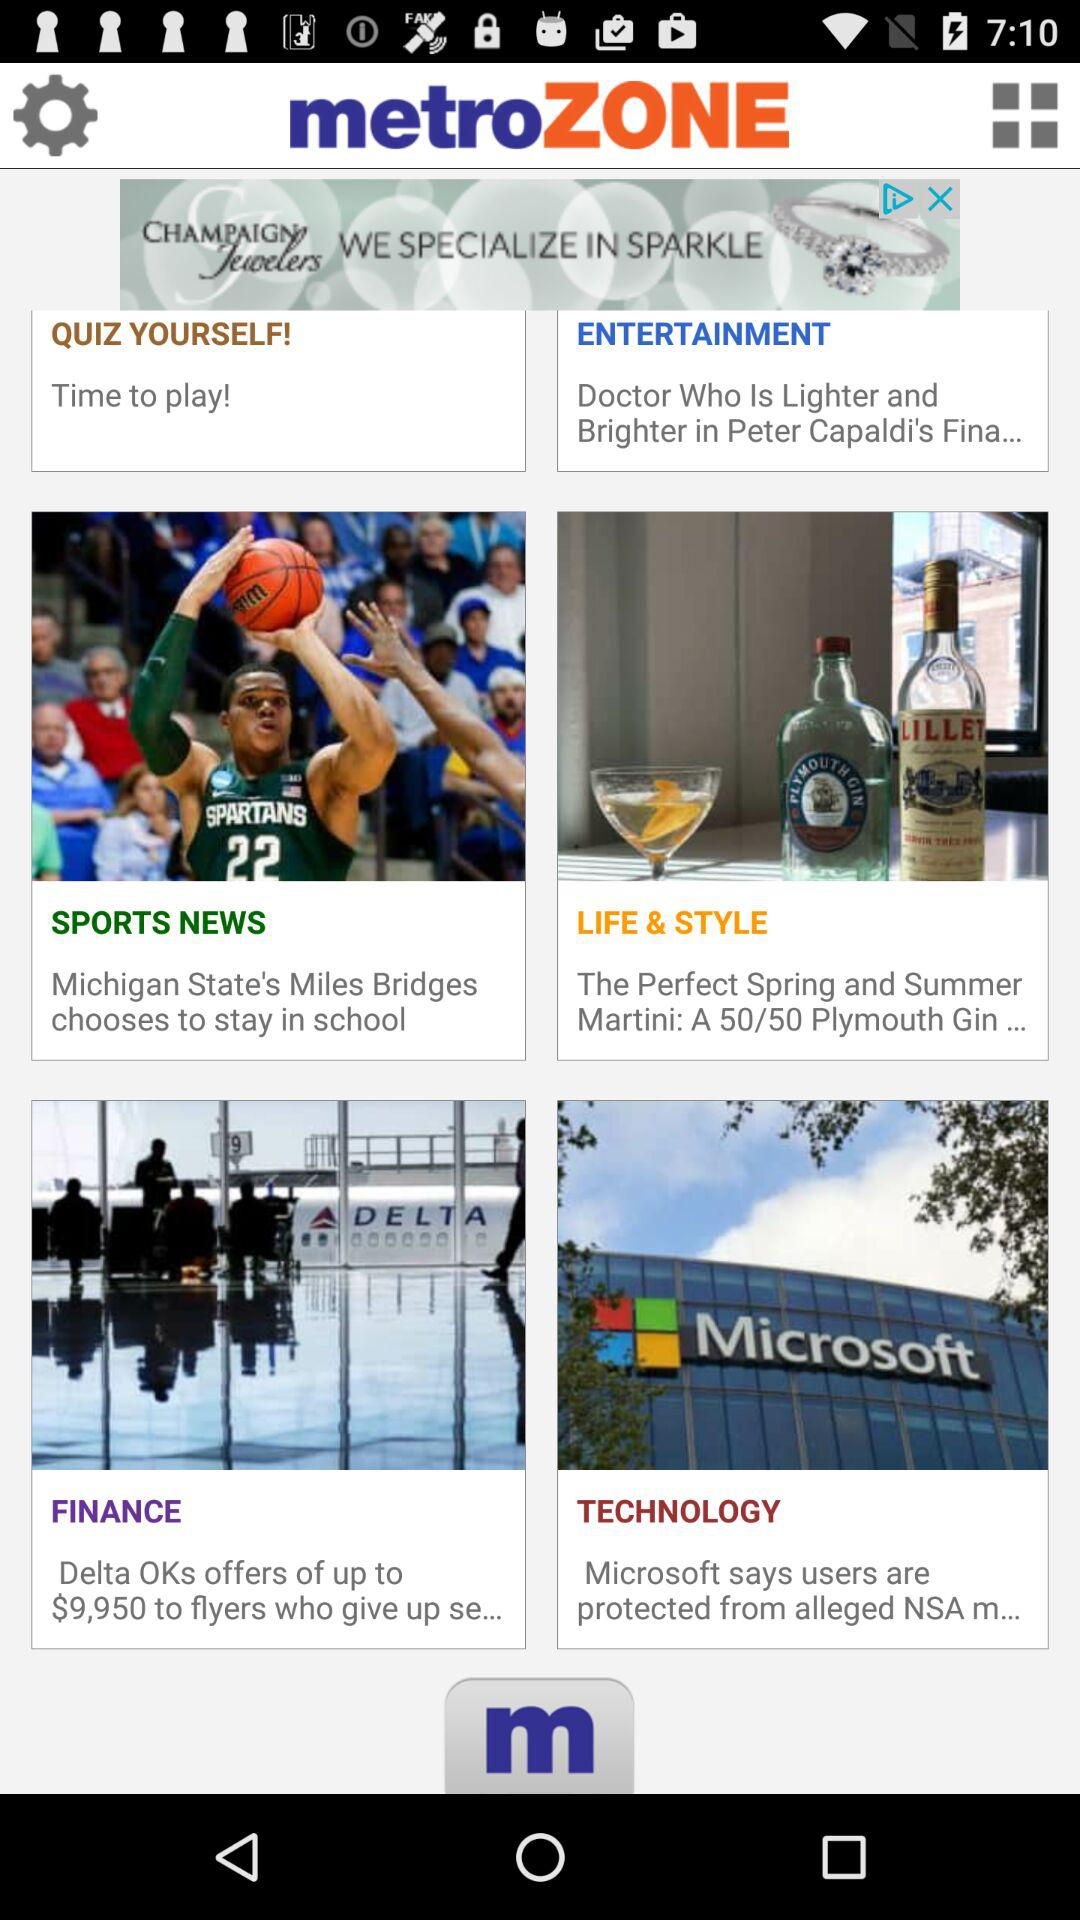How long is the quiz?
When the provided information is insufficient, respond with <no answer>. <no answer> 